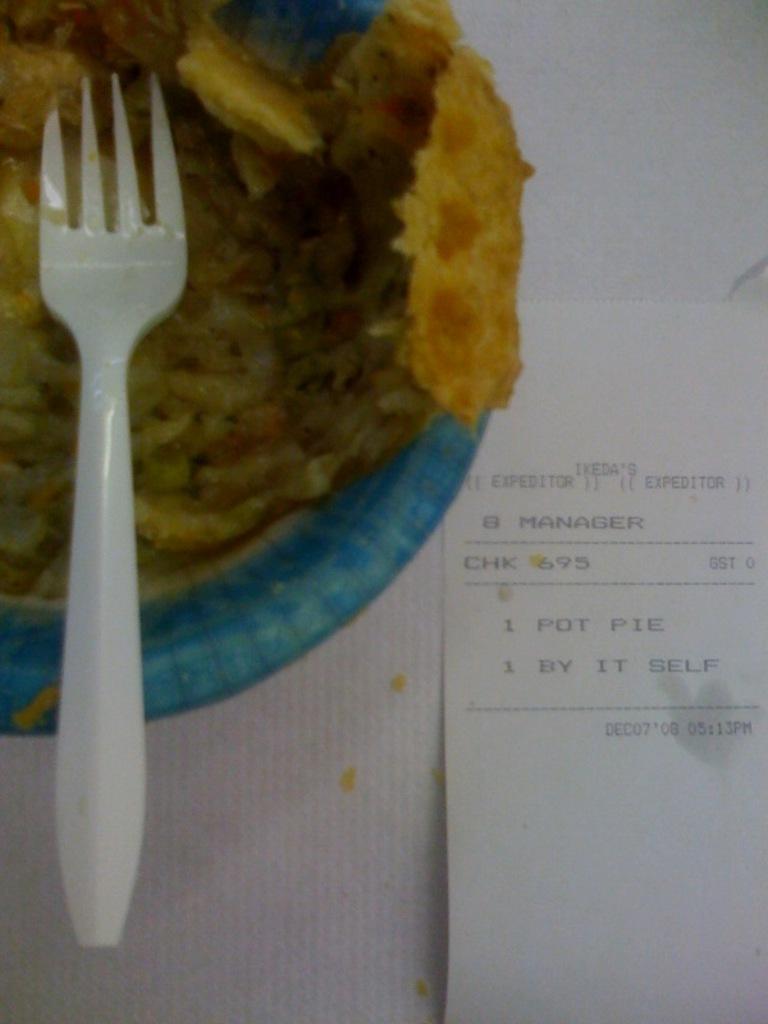In one or two sentences, can you explain what this image depicts? In this image I can see food in the bowl, the food is in brown color and the bowl is in blue color. I can also see a fork in white color, right side I can see a paper in white color. 